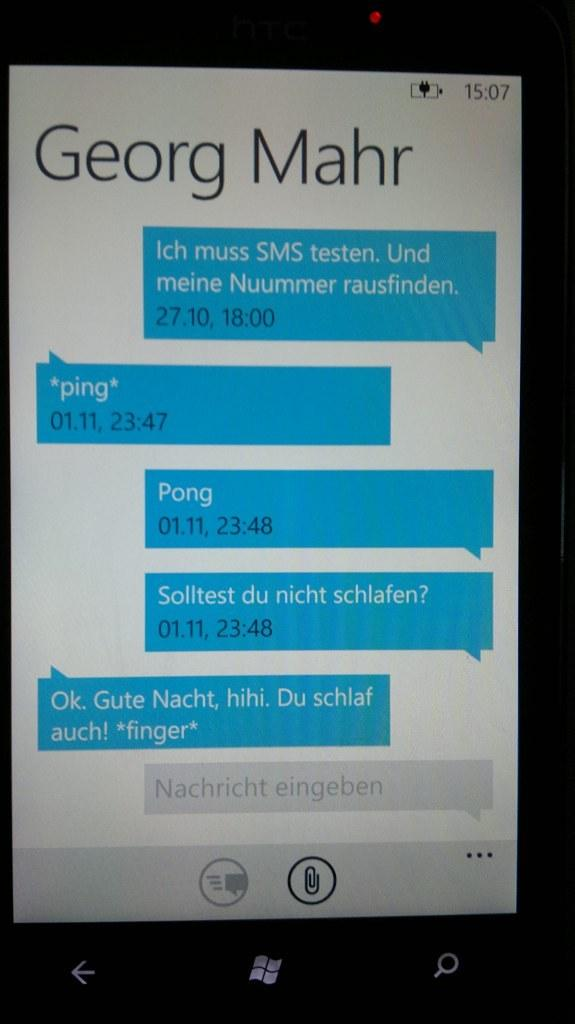<image>
Present a compact description of the photo's key features. The phone screen shows a conversion between the owner of this phone and Georg Mahr. 